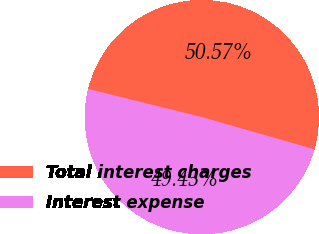Convert chart to OTSL. <chart><loc_0><loc_0><loc_500><loc_500><pie_chart><fcel>Total interest charges<fcel>Interest expense<nl><fcel>50.57%<fcel>49.43%<nl></chart> 